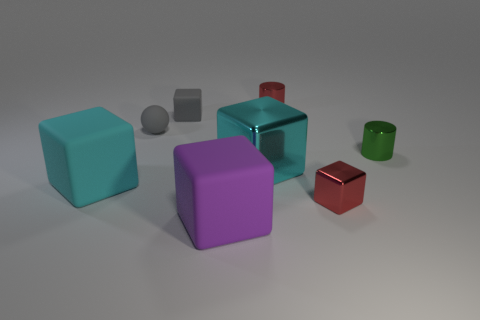Subtract all small red metal blocks. How many blocks are left? 4 Subtract all red blocks. How many blocks are left? 4 Subtract all brown cubes. Subtract all cyan cylinders. How many cubes are left? 5 Add 1 tiny green objects. How many objects exist? 9 Subtract all spheres. How many objects are left? 7 Add 6 green metallic cylinders. How many green metallic cylinders exist? 7 Subtract 0 yellow balls. How many objects are left? 8 Subtract all metallic cylinders. Subtract all big blocks. How many objects are left? 3 Add 1 gray matte things. How many gray matte things are left? 3 